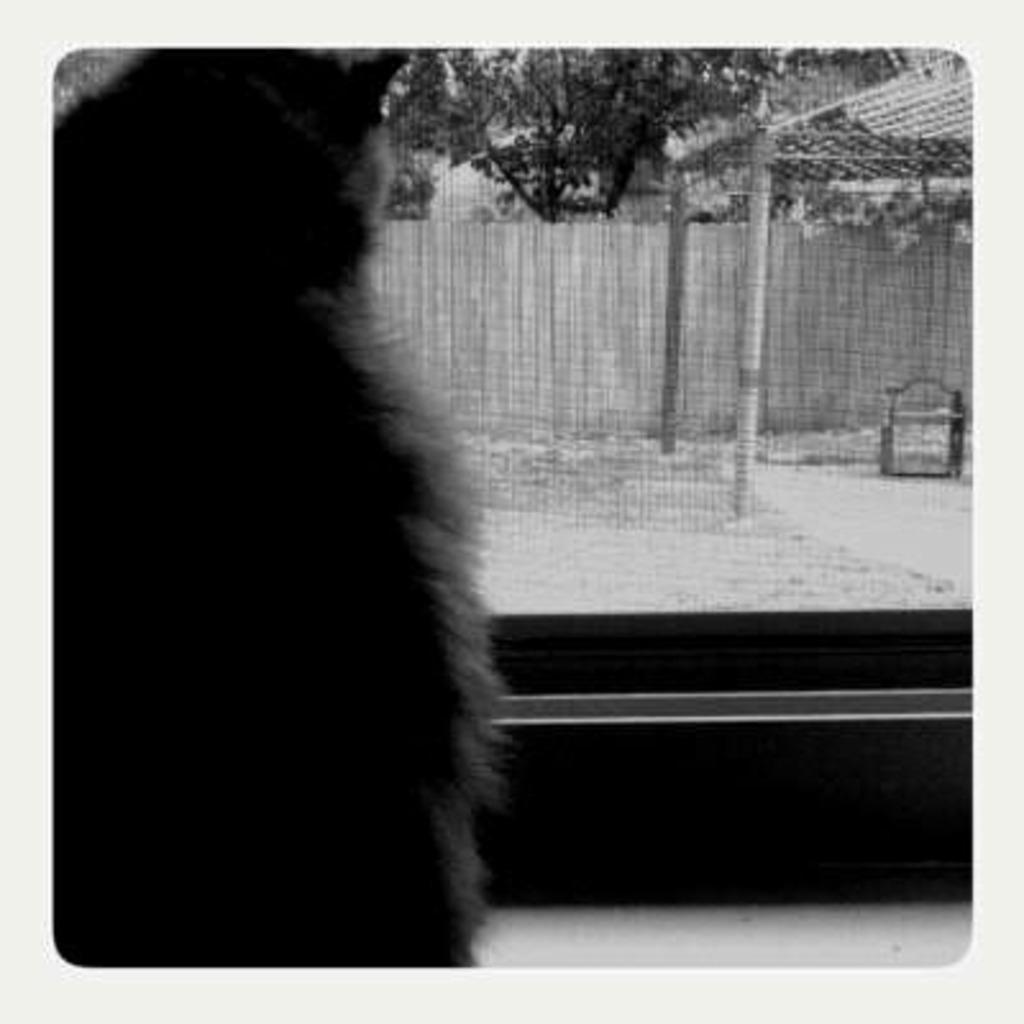What type of structure can be seen in the image? There is a wall in the image. What natural element is present in the image? There is a tree in the image. What man-made object can be seen in the image? There is a pole in the image. What type of design can be seen on the horses in the image? There are no horses present in the image; it only features a wall, a tree, and a pole. 